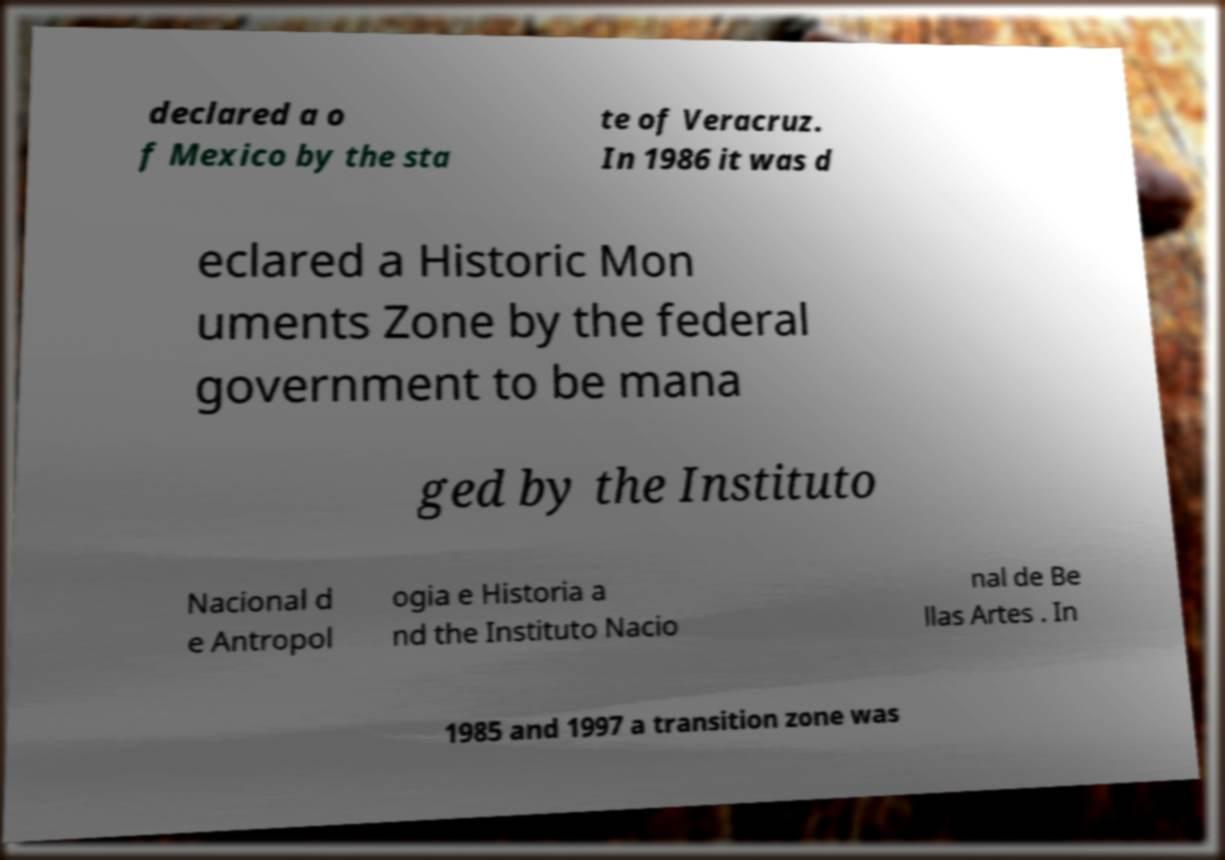Please read and relay the text visible in this image. What does it say? declared a o f Mexico by the sta te of Veracruz. In 1986 it was d eclared a Historic Mon uments Zone by the federal government to be mana ged by the Instituto Nacional d e Antropol ogia e Historia a nd the Instituto Nacio nal de Be llas Artes . In 1985 and 1997 a transition zone was 